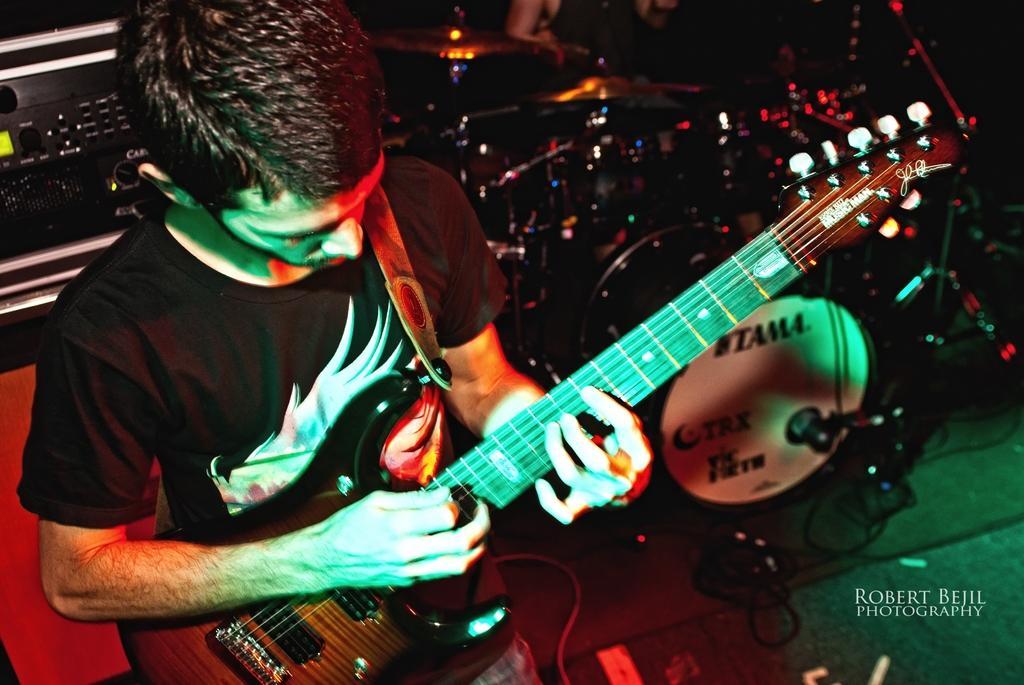Please provide a concise description of this image. A person is playing guitar behind him there are musical instruments. 